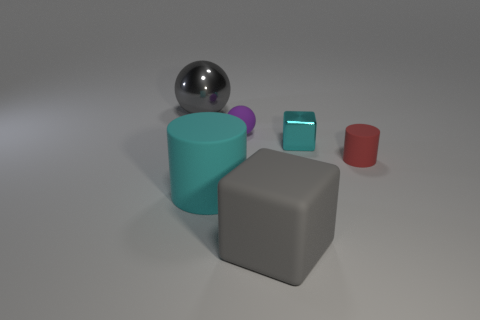What number of blocks are cyan things or tiny cyan metal things?
Your answer should be very brief. 1. There is a big object that is in front of the big cyan matte cylinder; is it the same color as the big cylinder?
Your response must be concise. No. The gray object left of the big block that is left of the cylinder that is right of the small sphere is made of what material?
Ensure brevity in your answer.  Metal. Does the red matte cylinder have the same size as the matte block?
Give a very brief answer. No. There is a matte sphere; does it have the same color as the shiny thing to the right of the matte ball?
Offer a very short reply. No. What is the shape of the tiny thing that is the same material as the gray sphere?
Provide a short and direct response. Cube. There is a matte thing that is on the right side of the big cube; is it the same shape as the small cyan metallic object?
Make the answer very short. No. What is the size of the metallic object on the left side of the matte object that is behind the red cylinder?
Provide a short and direct response. Large. There is a tiny thing that is made of the same material as the tiny cylinder; what color is it?
Make the answer very short. Purple. How many gray rubber objects have the same size as the red rubber cylinder?
Provide a succinct answer. 0. 